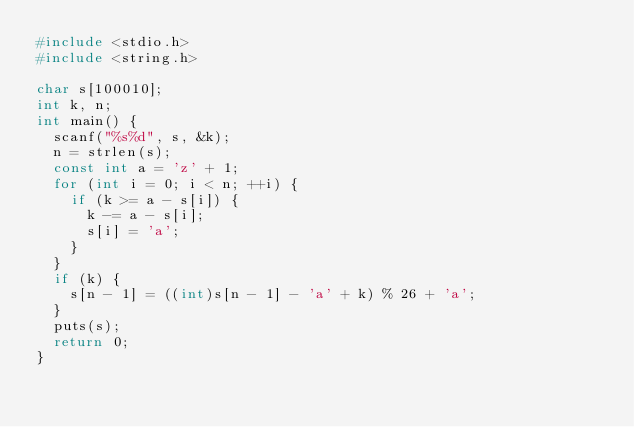<code> <loc_0><loc_0><loc_500><loc_500><_C_>#include <stdio.h>
#include <string.h>

char s[100010];
int k, n;
int main() {
  scanf("%s%d", s, &k);
  n = strlen(s);
  const int a = 'z' + 1;
  for (int i = 0; i < n; ++i) {
    if (k >= a - s[i]) {
      k -= a - s[i];
      s[i] = 'a';
    }
  }
  if (k) {
    s[n - 1] = ((int)s[n - 1] - 'a' + k) % 26 + 'a';
  }
  puts(s);
  return 0;
}
</code> 